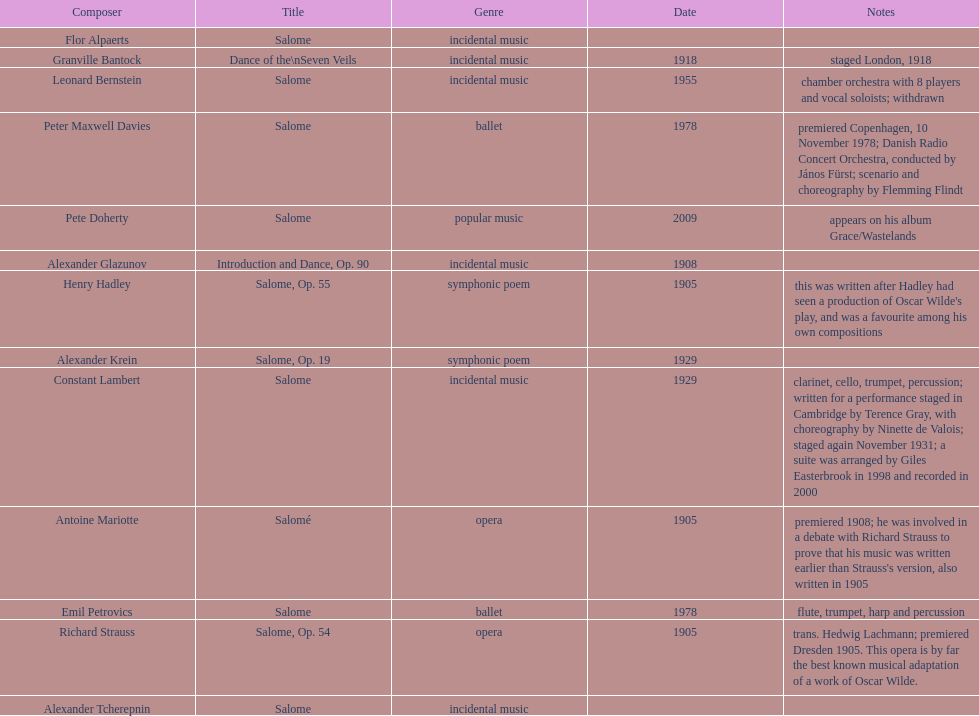How many are symphonic poems? 2. 